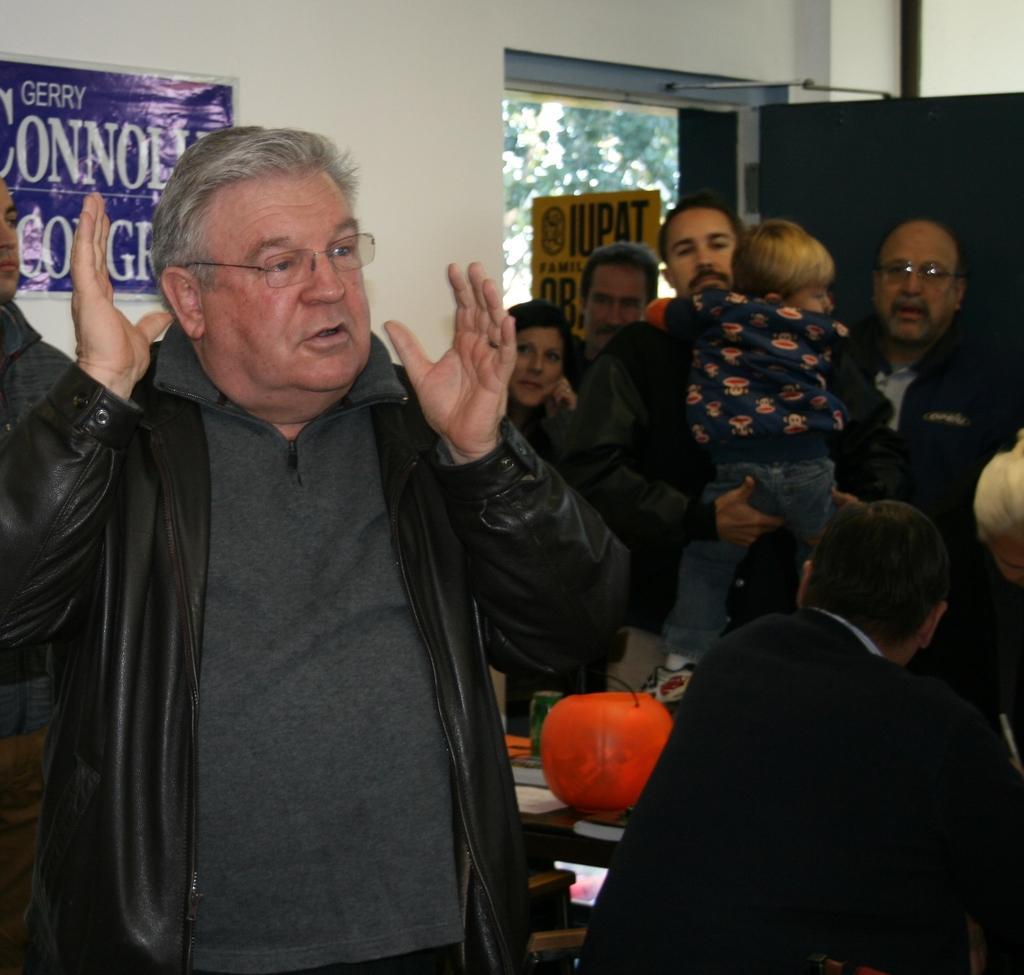Describe this image in one or two sentences. There is an union of IUPAT and a man is standing and speaking something and behind them there are some other people standing beside the door and in a background there is a wall. 